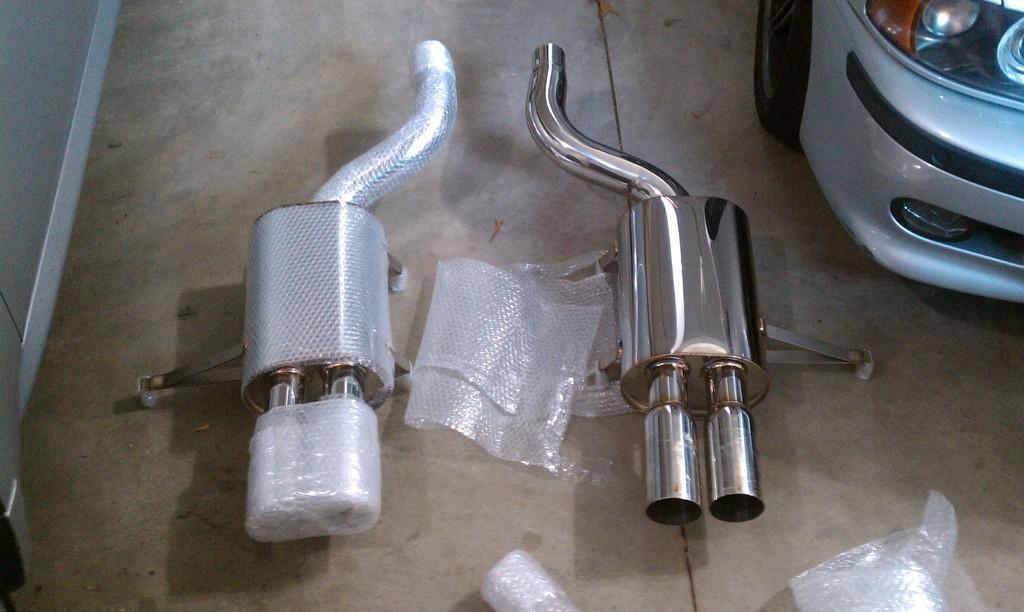How would you summarize this image in a sentence or two? These are the 2 stainless steel silencers, on the right side it's a vehicle. 